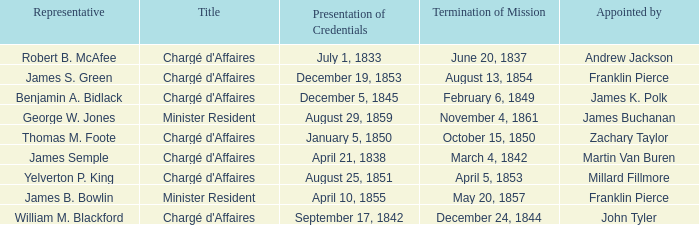Can you give me this table as a dict? {'header': ['Representative', 'Title', 'Presentation of Credentials', 'Termination of Mission', 'Appointed by'], 'rows': [['Robert B. McAfee', "Chargé d'Affaires", 'July 1, 1833', 'June 20, 1837', 'Andrew Jackson'], ['James S. Green', "Chargé d'Affaires", 'December 19, 1853', 'August 13, 1854', 'Franklin Pierce'], ['Benjamin A. Bidlack', "Chargé d'Affaires", 'December 5, 1845', 'February 6, 1849', 'James K. Polk'], ['George W. Jones', 'Minister Resident', 'August 29, 1859', 'November 4, 1861', 'James Buchanan'], ['Thomas M. Foote', "Chargé d'Affaires", 'January 5, 1850', 'October 15, 1850', 'Zachary Taylor'], ['James Semple', "Chargé d'Affaires", 'April 21, 1838', 'March 4, 1842', 'Martin Van Buren'], ['Yelverton P. King', "Chargé d'Affaires", 'August 25, 1851', 'April 5, 1853', 'Millard Fillmore'], ['James B. Bowlin', 'Minister Resident', 'April 10, 1855', 'May 20, 1857', 'Franklin Pierce'], ['William M. Blackford', "Chargé d'Affaires", 'September 17, 1842', 'December 24, 1844', 'John Tyler']]} What's the Representative listed that has a Presentation of Credentials of August 25, 1851? Yelverton P. King. 